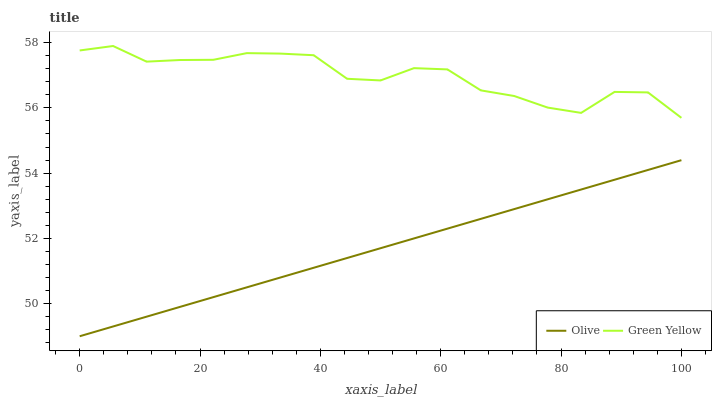Does Olive have the minimum area under the curve?
Answer yes or no. Yes. Does Green Yellow have the maximum area under the curve?
Answer yes or no. Yes. Does Green Yellow have the minimum area under the curve?
Answer yes or no. No. Is Olive the smoothest?
Answer yes or no. Yes. Is Green Yellow the roughest?
Answer yes or no. Yes. Is Green Yellow the smoothest?
Answer yes or no. No. Does Olive have the lowest value?
Answer yes or no. Yes. Does Green Yellow have the lowest value?
Answer yes or no. No. Does Green Yellow have the highest value?
Answer yes or no. Yes. Is Olive less than Green Yellow?
Answer yes or no. Yes. Is Green Yellow greater than Olive?
Answer yes or no. Yes. Does Olive intersect Green Yellow?
Answer yes or no. No. 